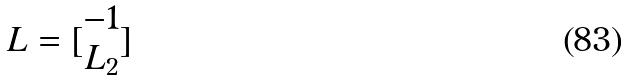<formula> <loc_0><loc_0><loc_500><loc_500>L = [ \begin{matrix} - 1 \\ L _ { 2 } \end{matrix} ]</formula> 